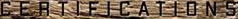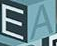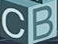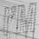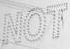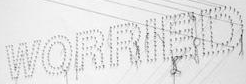What words are shown in these images in order, separated by a semicolon? CERTIFICATIONS; EA; CB; I'M; NOT; WORRIED 